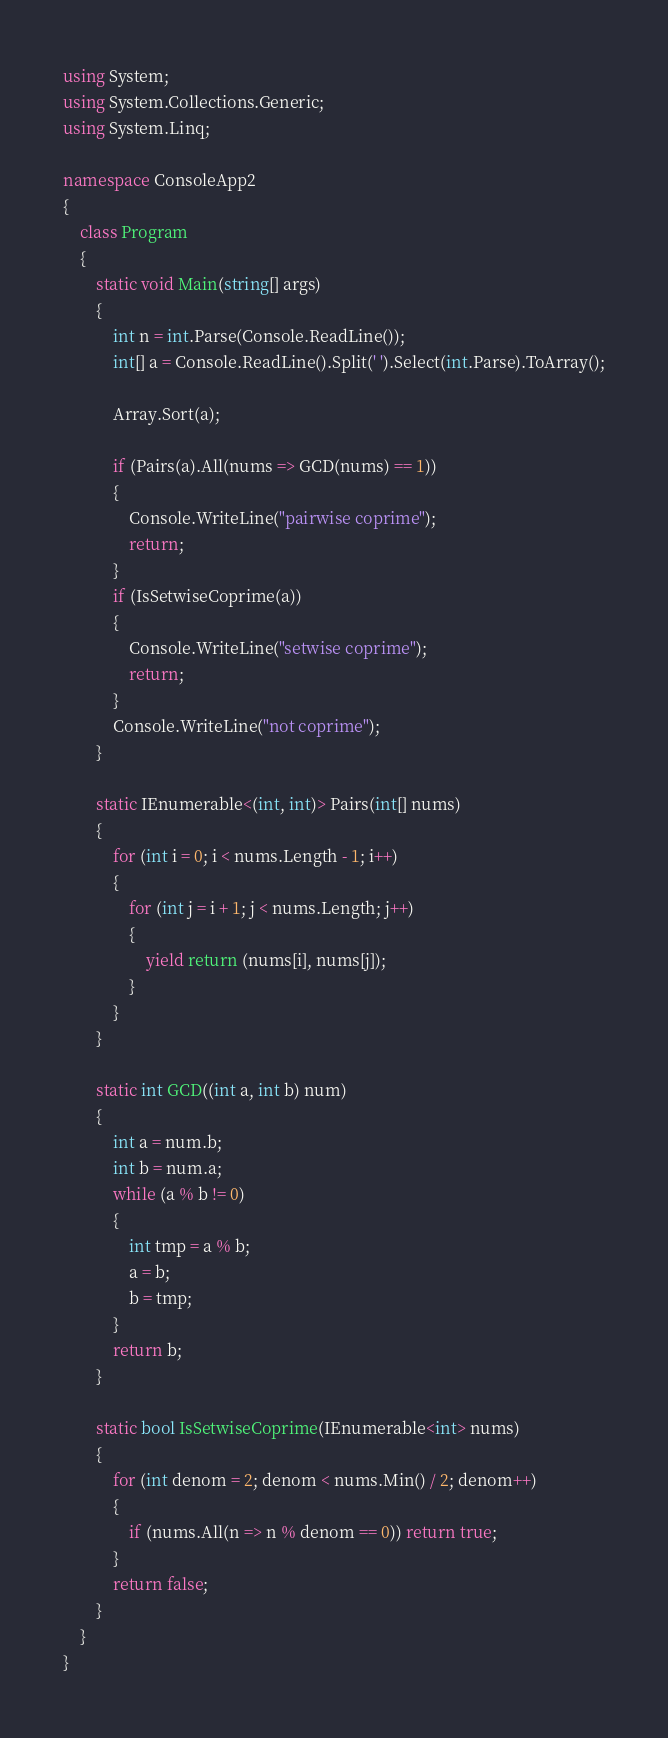Convert code to text. <code><loc_0><loc_0><loc_500><loc_500><_C#_>using System;
using System.Collections.Generic;
using System.Linq;

namespace ConsoleApp2
{
    class Program
    {
        static void Main(string[] args)
        {
            int n = int.Parse(Console.ReadLine());
            int[] a = Console.ReadLine().Split(' ').Select(int.Parse).ToArray();

            Array.Sort(a);

            if (Pairs(a).All(nums => GCD(nums) == 1))
            {
                Console.WriteLine("pairwise coprime");
                return;
            }
            if (IsSetwiseCoprime(a))
            {
                Console.WriteLine("setwise coprime");
                return;
            }
            Console.WriteLine("not coprime");
        }

        static IEnumerable<(int, int)> Pairs(int[] nums)
        {
            for (int i = 0; i < nums.Length - 1; i++)
            {
                for (int j = i + 1; j < nums.Length; j++)
                {
                    yield return (nums[i], nums[j]);
                }
            }
        }

        static int GCD((int a, int b) num)
        {
            int a = num.b;
            int b = num.a;
            while (a % b != 0)
            {
                int tmp = a % b;
                a = b;
                b = tmp;
            }
            return b;
        }

        static bool IsSetwiseCoprime(IEnumerable<int> nums)
        {
            for (int denom = 2; denom < nums.Min() / 2; denom++)
            {
                if (nums.All(n => n % denom == 0)) return true;
            }
            return false;
        }
    }
}</code> 